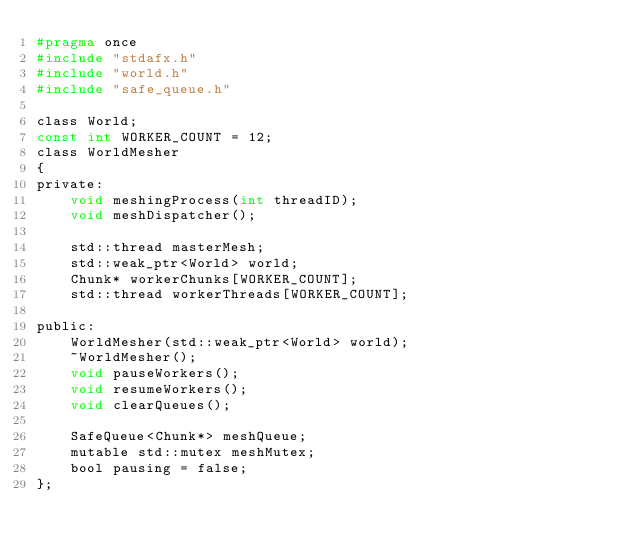<code> <loc_0><loc_0><loc_500><loc_500><_C_>#pragma once
#include "stdafx.h"
#include "world.h"
#include "safe_queue.h"

class World;
const int WORKER_COUNT = 12;
class WorldMesher
{
private:
	void meshingProcess(int threadID);
	void meshDispatcher();

	std::thread masterMesh;
	std::weak_ptr<World> world;
	Chunk* workerChunks[WORKER_COUNT];
	std::thread workerThreads[WORKER_COUNT];
	
public:
	WorldMesher(std::weak_ptr<World> world);
	~WorldMesher();
	void pauseWorkers();
	void resumeWorkers();
	void clearQueues();

	SafeQueue<Chunk*> meshQueue;
	mutable std::mutex meshMutex;
	bool pausing = false;
};
</code> 